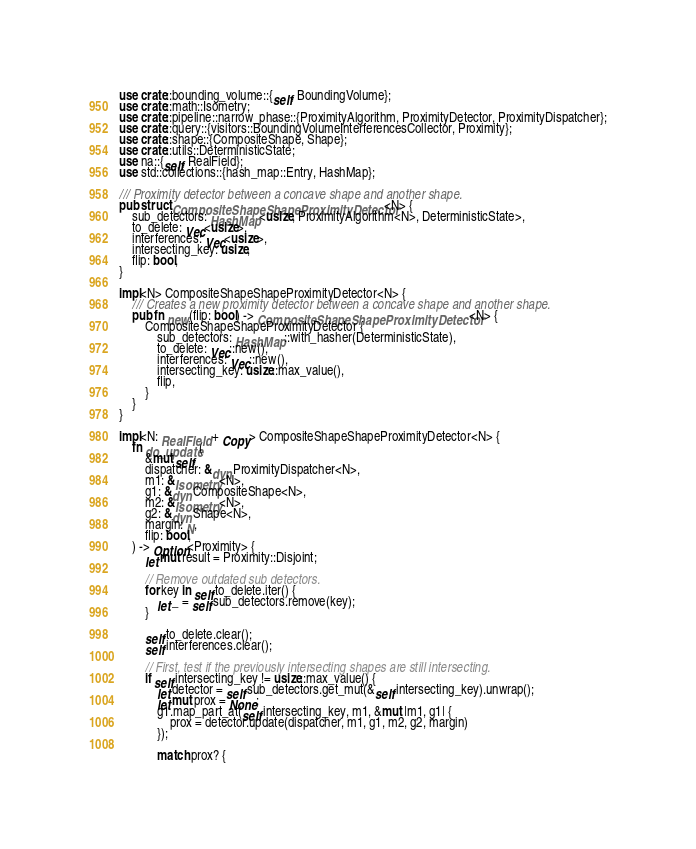Convert code to text. <code><loc_0><loc_0><loc_500><loc_500><_Rust_>use crate::bounding_volume::{self, BoundingVolume};
use crate::math::Isometry;
use crate::pipeline::narrow_phase::{ProximityAlgorithm, ProximityDetector, ProximityDispatcher};
use crate::query::{visitors::BoundingVolumeInterferencesCollector, Proximity};
use crate::shape::{CompositeShape, Shape};
use crate::utils::DeterministicState;
use na::{self, RealField};
use std::collections::{hash_map::Entry, HashMap};

/// Proximity detector between a concave shape and another shape.
pub struct CompositeShapeShapeProximityDetector<N> {
    sub_detectors: HashMap<usize, ProximityAlgorithm<N>, DeterministicState>,
    to_delete: Vec<usize>,
    interferences: Vec<usize>,
    intersecting_key: usize,
    flip: bool,
}

impl<N> CompositeShapeShapeProximityDetector<N> {
    /// Creates a new proximity detector between a concave shape and another shape.
    pub fn new(flip: bool) -> CompositeShapeShapeProximityDetector<N> {
        CompositeShapeShapeProximityDetector {
            sub_detectors: HashMap::with_hasher(DeterministicState),
            to_delete: Vec::new(),
            interferences: Vec::new(),
            intersecting_key: usize::max_value(),
            flip,
        }
    }
}

impl<N: RealField + Copy> CompositeShapeShapeProximityDetector<N> {
    fn do_update(
        &mut self,
        dispatcher: &dyn ProximityDispatcher<N>,
        m1: &Isometry<N>,
        g1: &dyn CompositeShape<N>,
        m2: &Isometry<N>,
        g2: &dyn Shape<N>,
        margin: N,
        flip: bool,
    ) -> Option<Proximity> {
        let mut result = Proximity::Disjoint;

        // Remove outdated sub detectors.
        for key in self.to_delete.iter() {
            let _ = self.sub_detectors.remove(key);
        }

        self.to_delete.clear();
        self.interferences.clear();

        // First, test if the previously intersecting shapes are still intersecting.
        if self.intersecting_key != usize::max_value() {
            let detector = self.sub_detectors.get_mut(&self.intersecting_key).unwrap();
            let mut prox = None;
            g1.map_part_at(self.intersecting_key, m1, &mut |m1, g1| {
                prox = detector.update(dispatcher, m1, g1, m2, g2, margin)
            });

            match prox? {</code> 